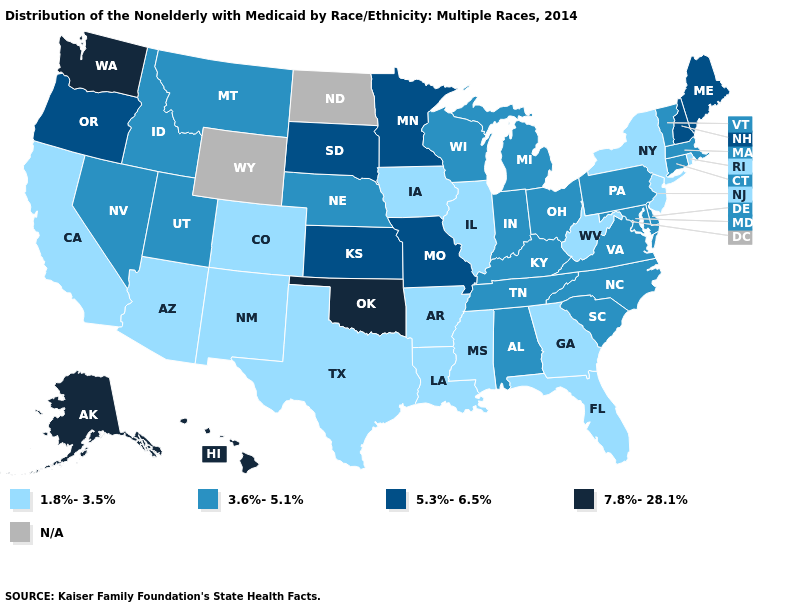What is the value of Texas?
Quick response, please. 1.8%-3.5%. Among the states that border Oklahoma , which have the lowest value?
Keep it brief. Arkansas, Colorado, New Mexico, Texas. Does Louisiana have the lowest value in the USA?
Keep it brief. Yes. Name the states that have a value in the range 7.8%-28.1%?
Short answer required. Alaska, Hawaii, Oklahoma, Washington. What is the value of Texas?
Give a very brief answer. 1.8%-3.5%. Which states have the lowest value in the USA?
Answer briefly. Arizona, Arkansas, California, Colorado, Florida, Georgia, Illinois, Iowa, Louisiana, Mississippi, New Jersey, New Mexico, New York, Rhode Island, Texas, West Virginia. What is the value of Alabama?
Give a very brief answer. 3.6%-5.1%. Which states have the highest value in the USA?
Concise answer only. Alaska, Hawaii, Oklahoma, Washington. What is the value of Michigan?
Short answer required. 3.6%-5.1%. Name the states that have a value in the range 5.3%-6.5%?
Keep it brief. Kansas, Maine, Minnesota, Missouri, New Hampshire, Oregon, South Dakota. Which states hav the highest value in the Northeast?
Give a very brief answer. Maine, New Hampshire. What is the value of South Dakota?
Short answer required. 5.3%-6.5%. What is the value of Iowa?
Short answer required. 1.8%-3.5%. Name the states that have a value in the range 1.8%-3.5%?
Answer briefly. Arizona, Arkansas, California, Colorado, Florida, Georgia, Illinois, Iowa, Louisiana, Mississippi, New Jersey, New Mexico, New York, Rhode Island, Texas, West Virginia. 